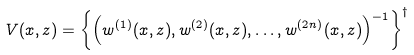<formula> <loc_0><loc_0><loc_500><loc_500>V ( x , z ) = \left \{ \left ( w ^ { ( 1 ) } ( x , z ) , w ^ { ( 2 ) } ( x , z ) , \dots , w ^ { ( 2 n ) } ( x , z ) \right ) ^ { - 1 } \right \} ^ { \dagger }</formula> 